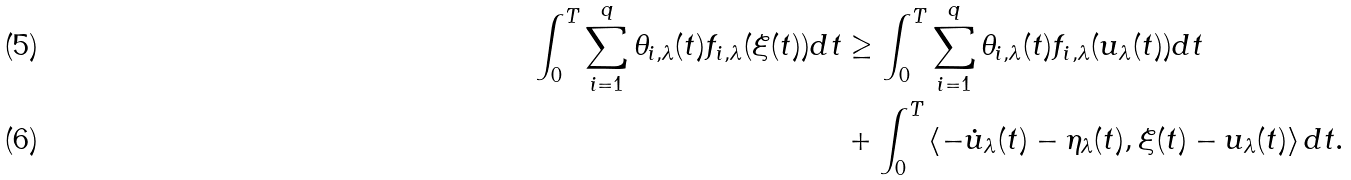Convert formula to latex. <formula><loc_0><loc_0><loc_500><loc_500>\int _ { 0 } ^ { T } \sum _ { i = 1 } ^ { q } \theta _ { i , \lambda } ( t ) f _ { i , \lambda } ( \xi ( t ) ) d t & \geq \int _ { 0 } ^ { T } \sum _ { i = 1 } ^ { q } \theta _ { i , \lambda } ( t ) f _ { i , \lambda } ( u _ { \lambda } ( t ) ) d t \\ & + \int _ { 0 } ^ { T } \left \langle - { \dot { u } } _ { \lambda } ( t ) - { \eta } _ { \lambda } ( t ) , \xi ( t ) - u _ { \lambda } ( t ) \right \rangle d t .</formula> 